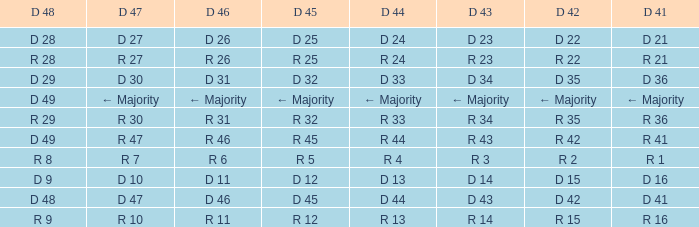Name the D 47 when it has a D 48 of d 49 and D 42 of r 42 R 47. 